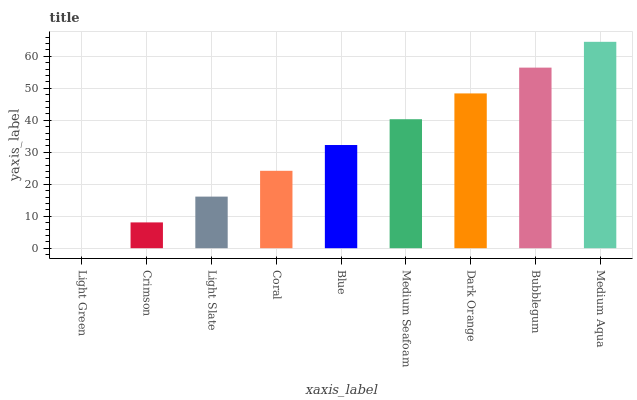Is Light Green the minimum?
Answer yes or no. Yes. Is Medium Aqua the maximum?
Answer yes or no. Yes. Is Crimson the minimum?
Answer yes or no. No. Is Crimson the maximum?
Answer yes or no. No. Is Crimson greater than Light Green?
Answer yes or no. Yes. Is Light Green less than Crimson?
Answer yes or no. Yes. Is Light Green greater than Crimson?
Answer yes or no. No. Is Crimson less than Light Green?
Answer yes or no. No. Is Blue the high median?
Answer yes or no. Yes. Is Blue the low median?
Answer yes or no. Yes. Is Crimson the high median?
Answer yes or no. No. Is Coral the low median?
Answer yes or no. No. 